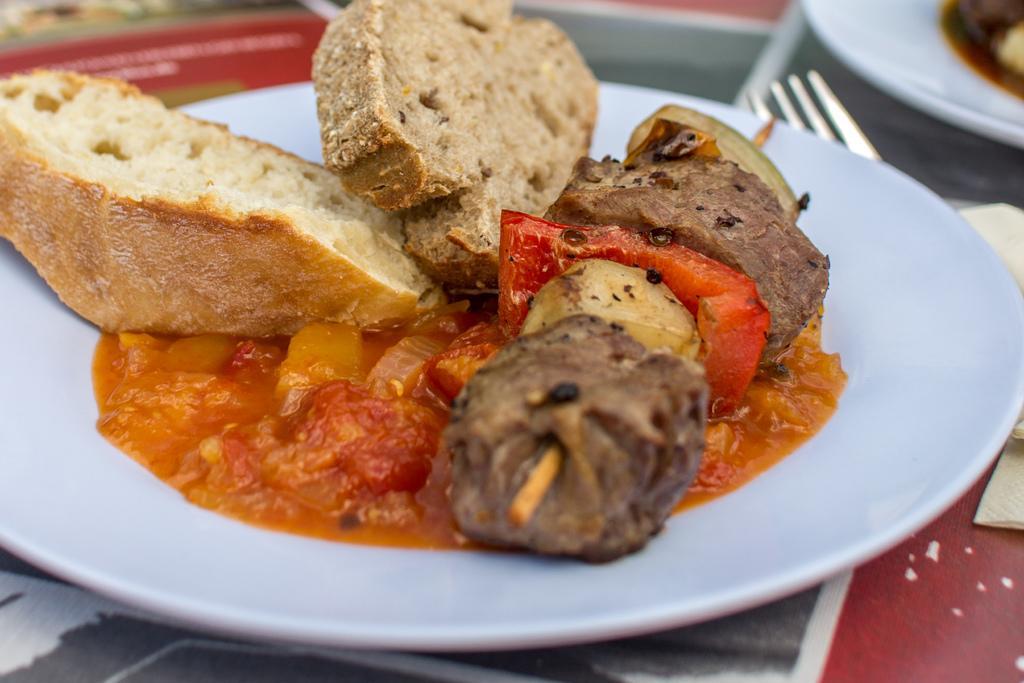Can you describe this image briefly? In this image, we can see food on the white plate. At the bottom, we can see surface. On the right side, we can see tissue papers, fork and food on the plate. Top of the image, there is a blur view. 